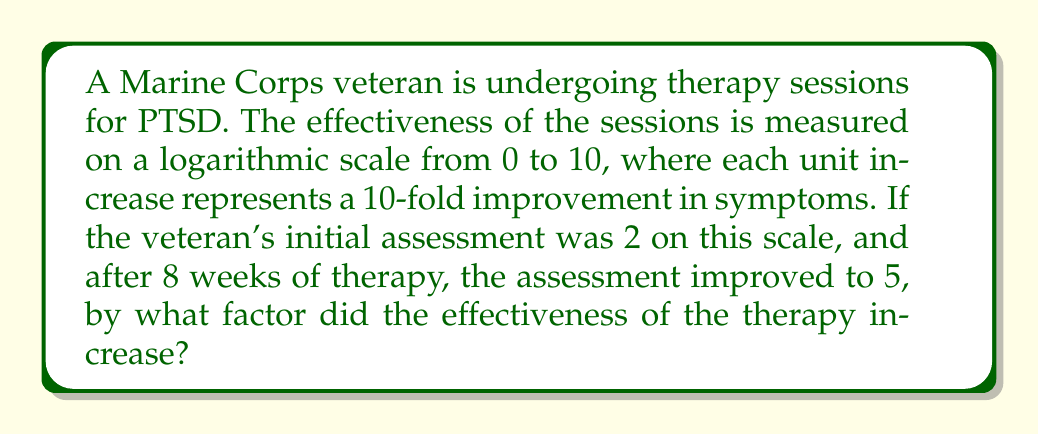Teach me how to tackle this problem. Let's approach this step-by-step:

1) The logarithmic scale used here is base 10, as each unit increase represents a 10-fold improvement.

2) The initial assessment was 2, which can be expressed as:
   $$10^2 = 100$$

3) The final assessment was 5, which can be expressed as:
   $$10^5 = 100,000$$

4) To find the factor of improvement, we divide the final value by the initial value:
   $$\frac{10^5}{10^2} = \frac{100,000}{100}$$

5) This can be simplified using the laws of exponents:
   $$10^{5-2} = 10^3 = 1,000$$

6) Therefore, the effectiveness of the therapy increased by a factor of 1,000.

This means that the therapy sessions resulted in a 1,000-fold improvement in the veteran's PTSD symptoms over the 8-week period, according to this logarithmic scale.
Answer: 1,000 